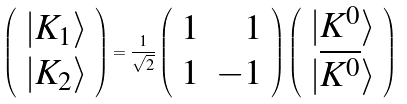Convert formula to latex. <formula><loc_0><loc_0><loc_500><loc_500>\left ( \begin{array} { c } { { | K _ { 1 } \rangle } } \\ { { | K _ { 2 } \rangle } } \end{array} \right ) = \frac { 1 } { \sqrt { 2 } } \left ( \begin{array} { r r } { 1 } & { 1 } \\ { 1 } & { - 1 } \end{array} \right ) \left ( \begin{array} { c } { { | K ^ { 0 } \rangle } } \\ { { | \overline { { { K ^ { 0 } } } } \rangle } } \end{array} \right )</formula> 